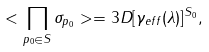<formula> <loc_0><loc_0><loc_500><loc_500>< \prod _ { p _ { 0 } \in S } \sigma _ { p _ { 0 } } > = 3 D [ \gamma _ { e f f } ( \lambda ) ] ^ { S _ { 0 } } ,</formula> 